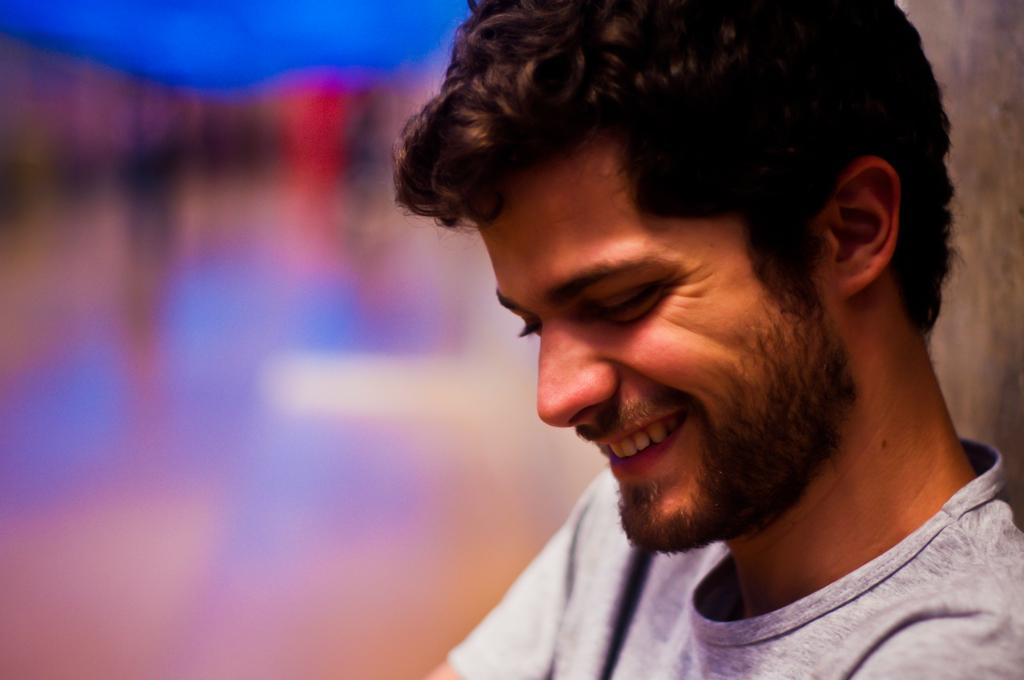What is the main subject in the foreground of the picture? There is a person in the foreground of the picture. What is the person doing in the image? The person is smiling. Can you describe the background of the image? The background of the image is blurred. What type of seed can be seen growing on the person's shoulder in the image? There is no seed visible on the person's shoulder in the image. What leaf is the person holding in their hand in the image? There is no leaf present in the image. 